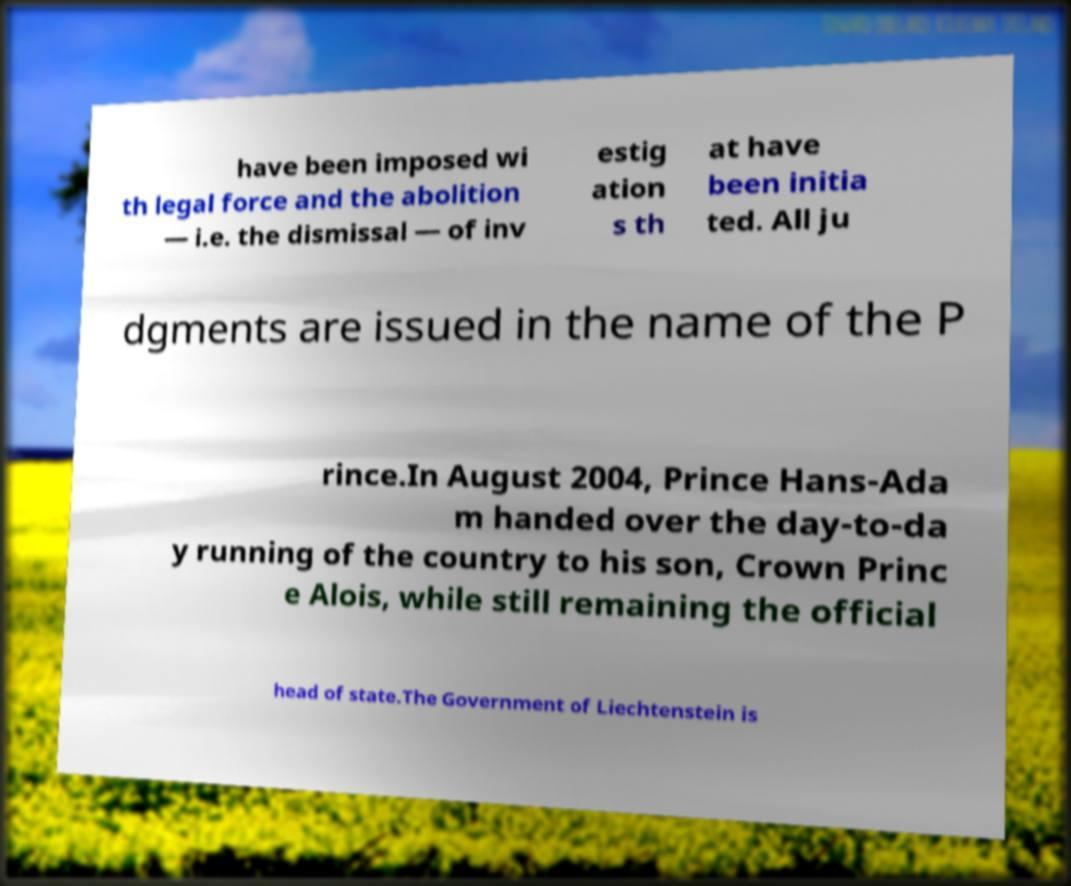Please identify and transcribe the text found in this image. have been imposed wi th legal force and the abolition — i.e. the dismissal — of inv estig ation s th at have been initia ted. All ju dgments are issued in the name of the P rince.In August 2004, Prince Hans-Ada m handed over the day-to-da y running of the country to his son, Crown Princ e Alois, while still remaining the official head of state.The Government of Liechtenstein is 